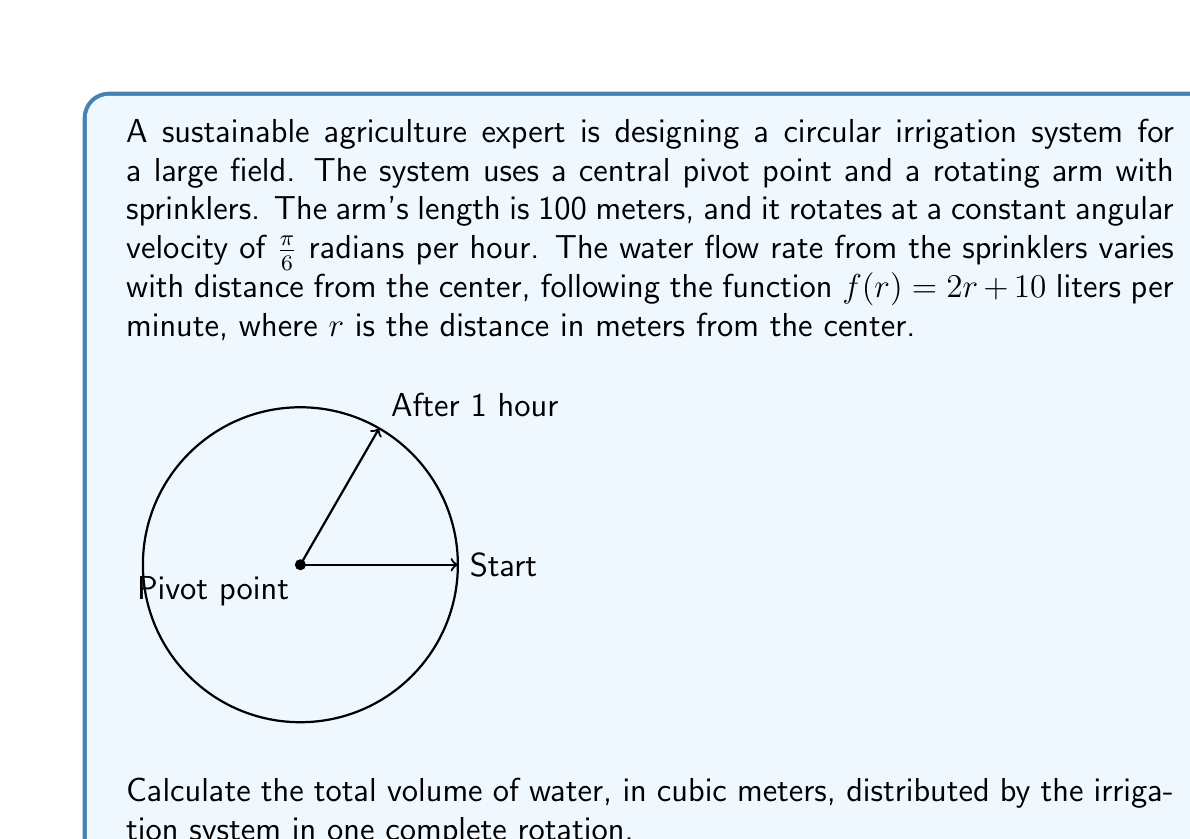Provide a solution to this math problem. Let's approach this step-by-step:

1) First, we need to find the time for one complete rotation:
   $$\text{Time} = \frac{2\pi}{\text{angular velocity}} = \frac{2\pi}{\pi/6} = 12 \text{ hours}$$

2) Now, we need to integrate the water flow rate over the arm's length and over the rotation time. We'll use polar coordinates for this.

3) The water flow rate is given in liters per minute, but we need cubic meters per hour:
   $$f(r) = (2r + 10) \cdot \frac{60}{1000} = 0.12r + 0.6 \text{ m}^3/\text{hour}$$

4) The volume element in polar coordinates is $r \, dr \, d\theta$. Over one rotation, $\theta$ goes from 0 to $2\pi$.

5) The integral for the total volume is:
   $$V = \int_0^{2\pi} \int_0^{100} (0.12r + 0.6) \cdot r \, dr \, d\theta$$

6) Let's solve the inner integral first:
   $$\int_0^{100} (0.12r^2 + 0.6r) \, dr = [0.04r^3 + 0.3r^2]_0^{100}$$
   $$= (40000 + 3000) - (0 + 0) = 43000$$

7) Now the outer integral:
   $$V = \int_0^{2\pi} 43000 \, d\theta = 43000 \cdot 2\pi = 270176.8 \text{ m}^3$$

Therefore, the total volume of water distributed in one complete rotation is approximately 270,177 cubic meters.
Answer: 270,177 m³ 